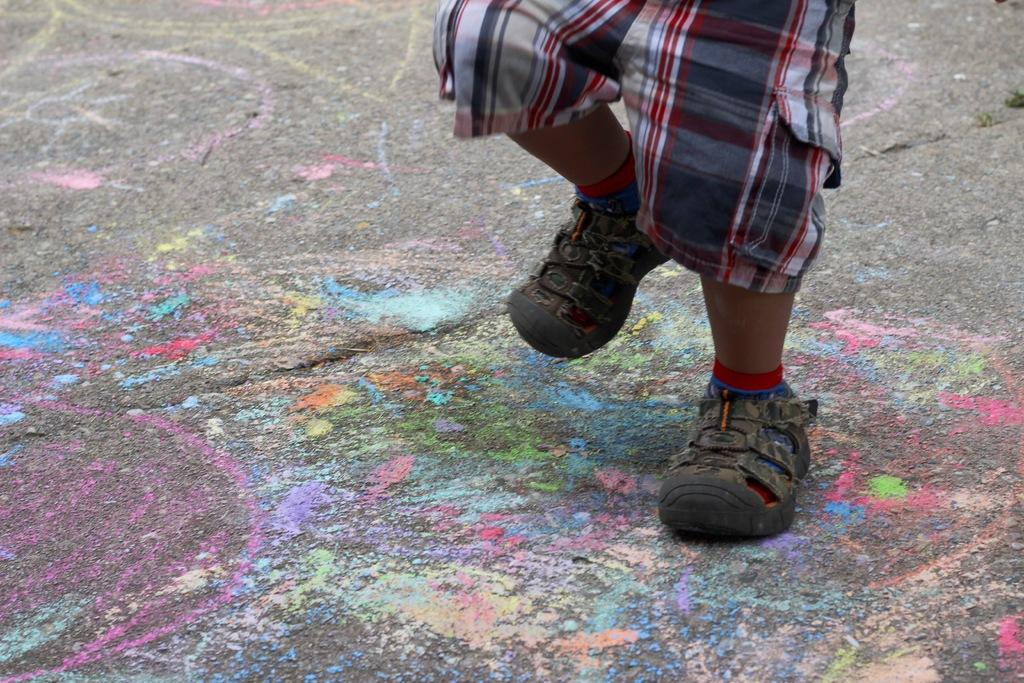What type of footwear is visible in the image? There is footwear in the image, but the specific type cannot be determined from the provided facts. What else can be seen in the image besides the footwear? The legs of a person are visible in the image. What is on the ground in the image? There are colorful things on the ground in the image. What type of insurance policy is being discussed in the image? There is no mention of insurance or any discussion in the image, as it primarily focuses on footwear, legs, and colorful things on the ground. 